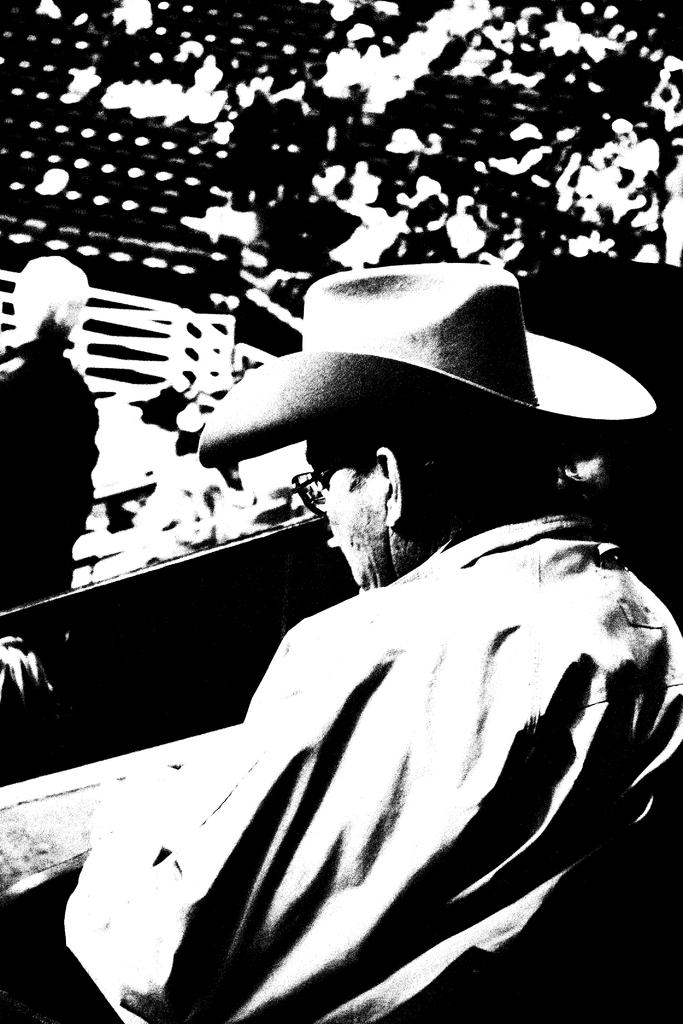What is the color scheme of the image? The image is black and white. Who is the main subject in the image? There is a person wearing a hat in the middle of the image. What can be seen in the background of the image? There is a group of people in the background of the image. What is the color of the background? The background color is black. How does the person in the image use the brake while wearing the hat? There is no brake present in the image, and the person is not performing any actions related to a brake. 